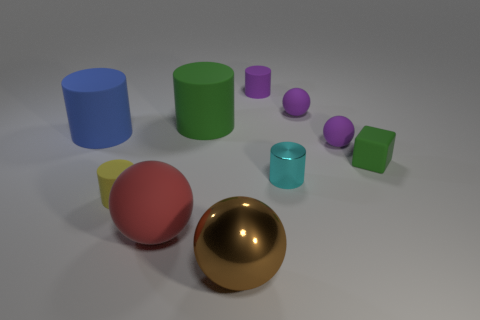How many tiny objects are brown things or rubber cylinders?
Provide a succinct answer. 2. There is a red matte ball; does it have the same size as the cylinder to the left of the yellow cylinder?
Your response must be concise. Yes. Is there any other thing that is the same shape as the big red rubber thing?
Provide a short and direct response. Yes. What number of purple matte cylinders are there?
Make the answer very short. 1. What number of blue objects are either big matte cylinders or matte objects?
Your answer should be very brief. 1. Are the green object on the left side of the green rubber cube and the green cube made of the same material?
Your response must be concise. Yes. How many other things are the same material as the big green object?
Your answer should be very brief. 7. What is the material of the block?
Your response must be concise. Rubber. How big is the matte sphere that is in front of the tiny yellow cylinder?
Your answer should be compact. Large. There is a matte ball behind the blue rubber object; how many tiny things are on the right side of it?
Offer a terse response. 2. 